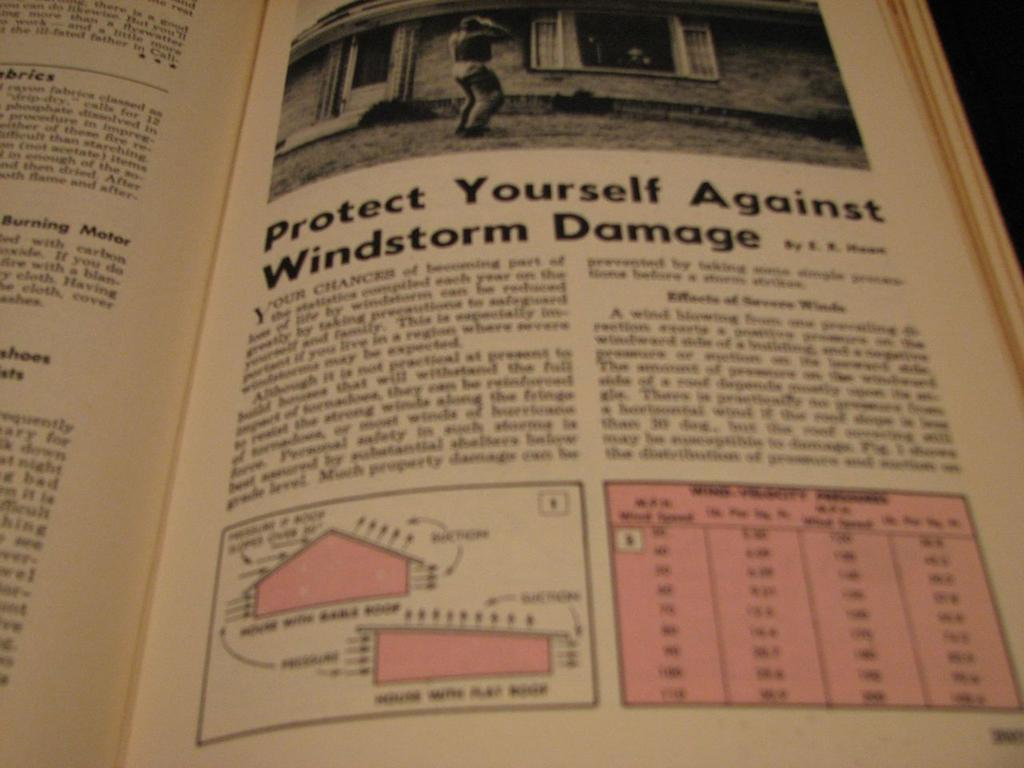<image>
Render a clear and concise summary of the photo. The book is open to an article about protecting yourself against windstorm damage. 